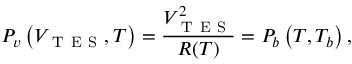<formula> <loc_0><loc_0><loc_500><loc_500>P _ { v } \left ( V _ { T E S } , T \right ) = \frac { V _ { T E S } ^ { 2 } } { R ( T ) } = P _ { b } \left ( T , T _ { b } \right ) ,</formula> 